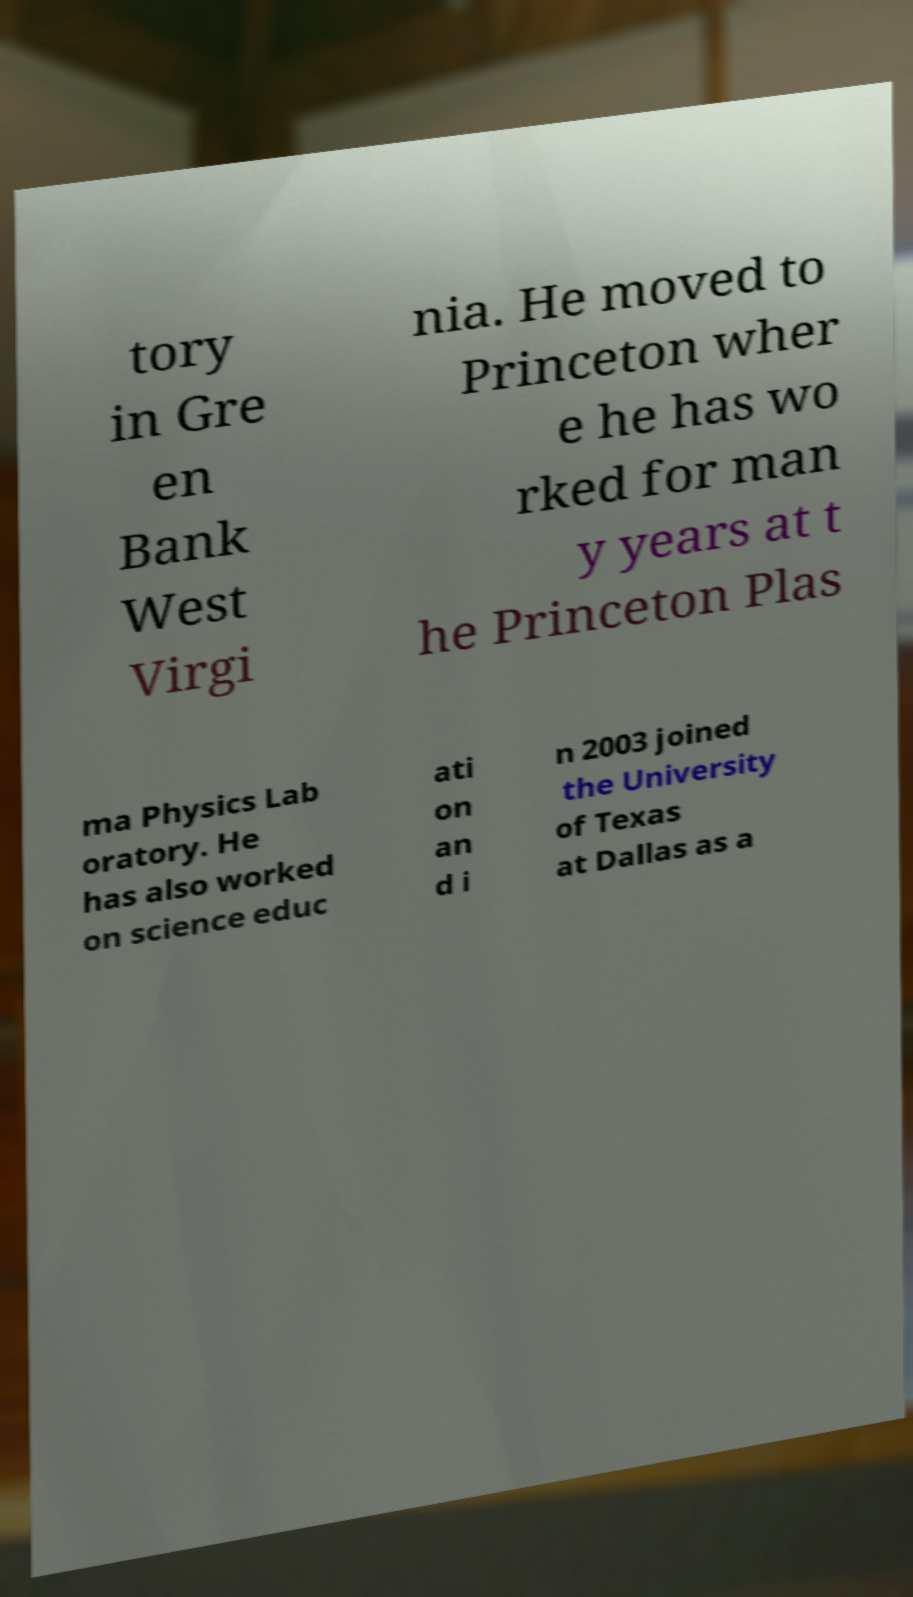For documentation purposes, I need the text within this image transcribed. Could you provide that? tory in Gre en Bank West Virgi nia. He moved to Princeton wher e he has wo rked for man y years at t he Princeton Plas ma Physics Lab oratory. He has also worked on science educ ati on an d i n 2003 joined the University of Texas at Dallas as a 